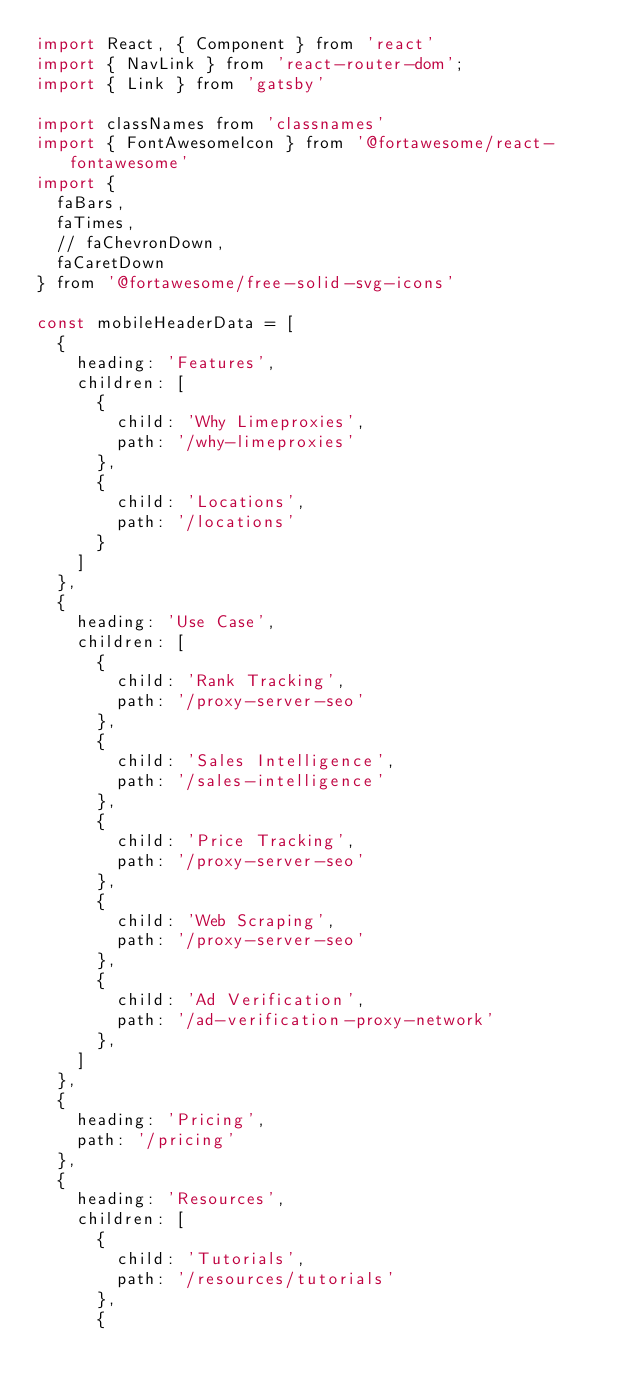Convert code to text. <code><loc_0><loc_0><loc_500><loc_500><_JavaScript_>import React, { Component } from 'react'
import { NavLink } from 'react-router-dom';
import { Link } from 'gatsby'

import classNames from 'classnames'
import { FontAwesomeIcon } from '@fortawesome/react-fontawesome'
import { 
  faBars,
  faTimes,
  // faChevronDown,
  faCaretDown 
} from '@fortawesome/free-solid-svg-icons'

const mobileHeaderData = [
  {
    heading: 'Features',
    children: [
      {
        child: 'Why Limeproxies',
        path: '/why-limeproxies'
      },
      {
        child: 'Locations',
        path: '/locations'
      }
    ]
  },
  {
    heading: 'Use Case',
    children: [
      {
        child: 'Rank Tracking',
        path: '/proxy-server-seo'
      },
      {
        child: 'Sales Intelligence',
        path: '/sales-intelligence'
      },
      {
        child: 'Price Tracking',
        path: '/proxy-server-seo'
      },
      {
        child: 'Web Scraping',
        path: '/proxy-server-seo'
      },
      {
        child: 'Ad Verification',
        path: '/ad-verification-proxy-network'
      },
    ]
  },
  {
    heading: 'Pricing',
    path: '/pricing'
  },
  {
    heading: 'Resources',
    children: [
      {
        child: 'Tutorials',
        path: '/resources/tutorials'
      },
      {</code> 